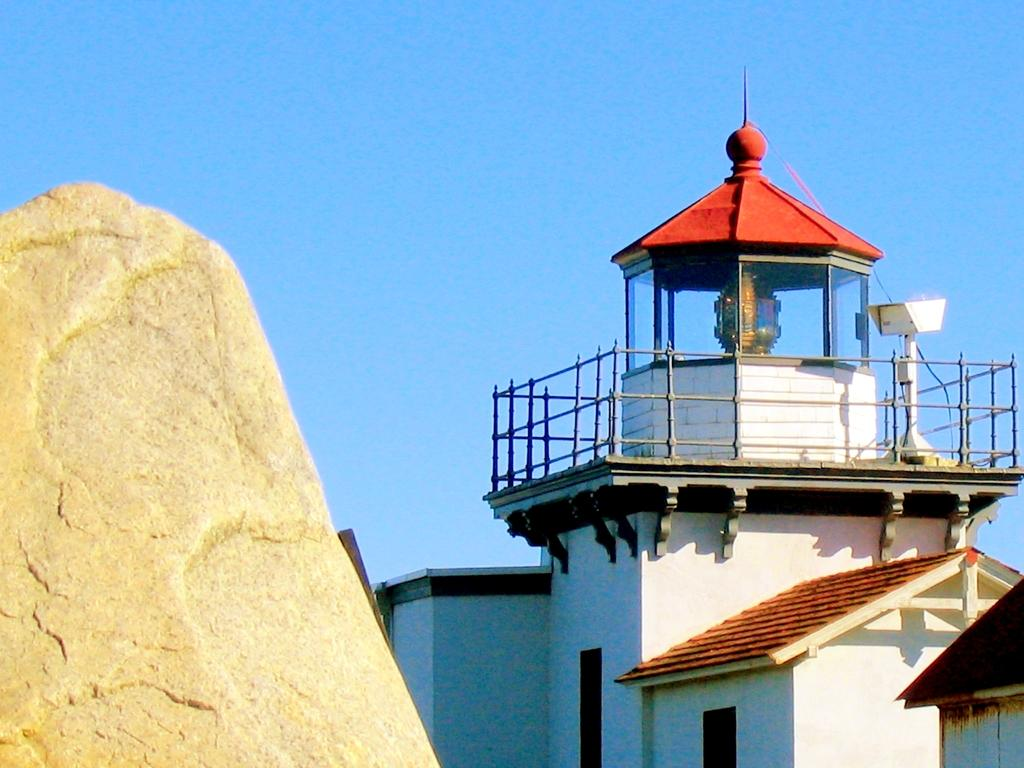What type of structure is visible in the image? There is a house in the image. What object can be seen on the left side of the image? There is a stone on the left side of the image. What color is the sky in the background of the image? The sky is blue in the background of the image. Can you see any owls in the aftermath of the party in the image? There is no mention of an owl, aftermath, or party in the image. The image features a house, a stone, and a blue sky. 